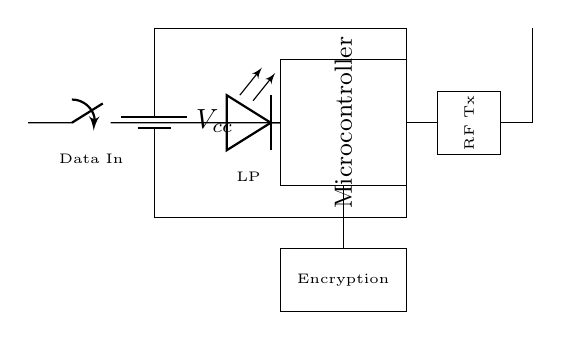What component is used for wireless transmission? The circuit includes an RF transmitter specifically designed for wireless data transmission, shown as "RF Tx".
Answer: RF Tx What does the LED indicate? The LED labeled "LP" indicates the low-power operation of the device, functioning as an indicator that the circuit is consuming minimal power.
Answer: Low-power operation Which module is responsible for data encryption? The encryption module is clearly labeled as "Encryption" in the circuit diagram, indicating its role in securing the data being transmitted.
Answer: Encryption What is the power supply voltage? The circuit specifies a battery as the power supply labeled "Vcc"; however, it does not indicate an exact voltage value.
Answer: Vcc How is the microcontroller connected to the antenna? The microcontroller connects to the RF transmitter, which is directly linked to the antenna, enabling the control of wireless signal output.
Answer: Via RF Tx What is the purpose of the switch in the circuit? The switch labeled "Data In" serves as a control mechanism for initiating the secure data input into the system, allowing data to be fed into the microcontroller.
Answer: Control mechanism How many primary functional components are in the circuit? By analyzing the components noted in the circuit, there are four primary functional components: power supply, microcontroller, RF transmitter, and encryption module.
Answer: Four 